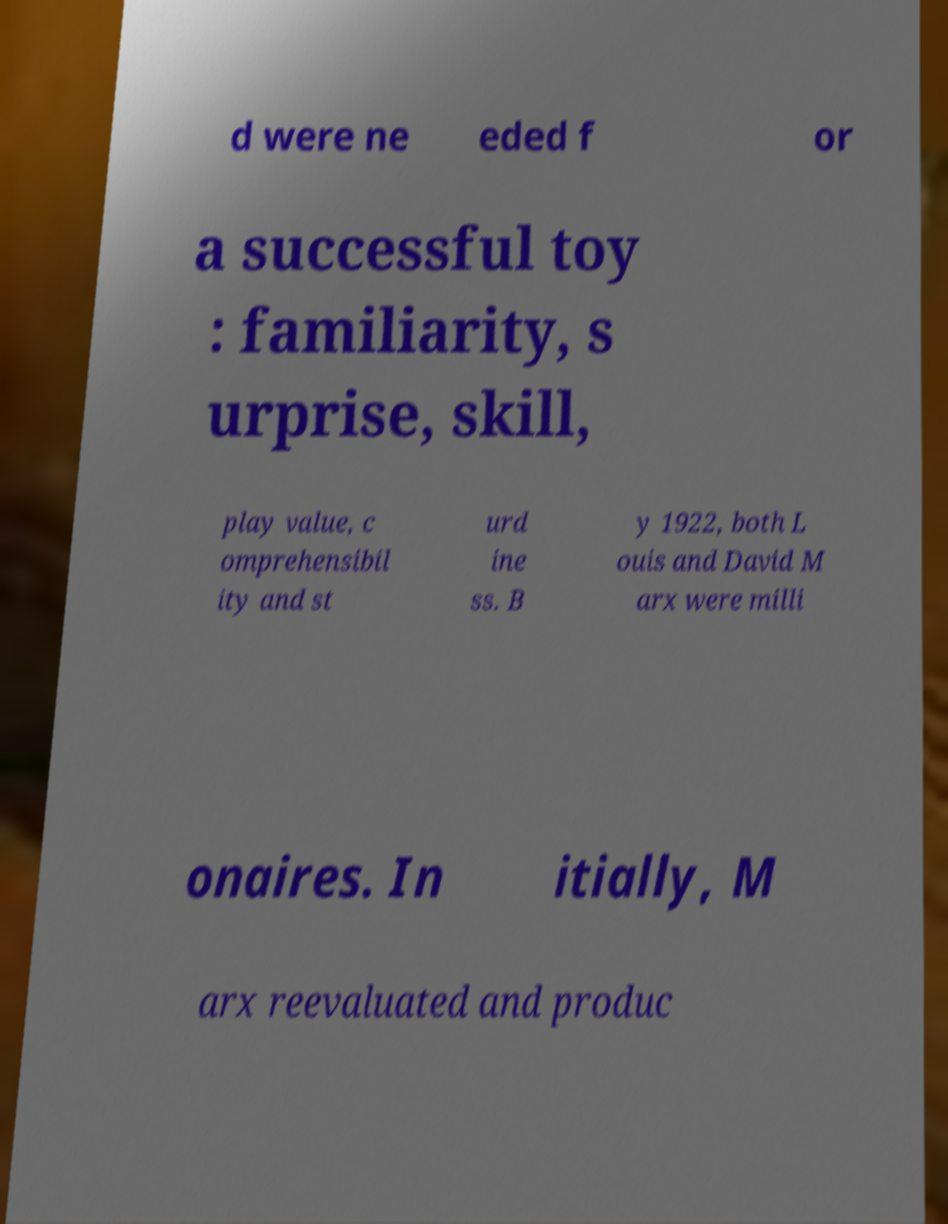I need the written content from this picture converted into text. Can you do that? d were ne eded f or a successful toy : familiarity, s urprise, skill, play value, c omprehensibil ity and st urd ine ss. B y 1922, both L ouis and David M arx were milli onaires. In itially, M arx reevaluated and produc 